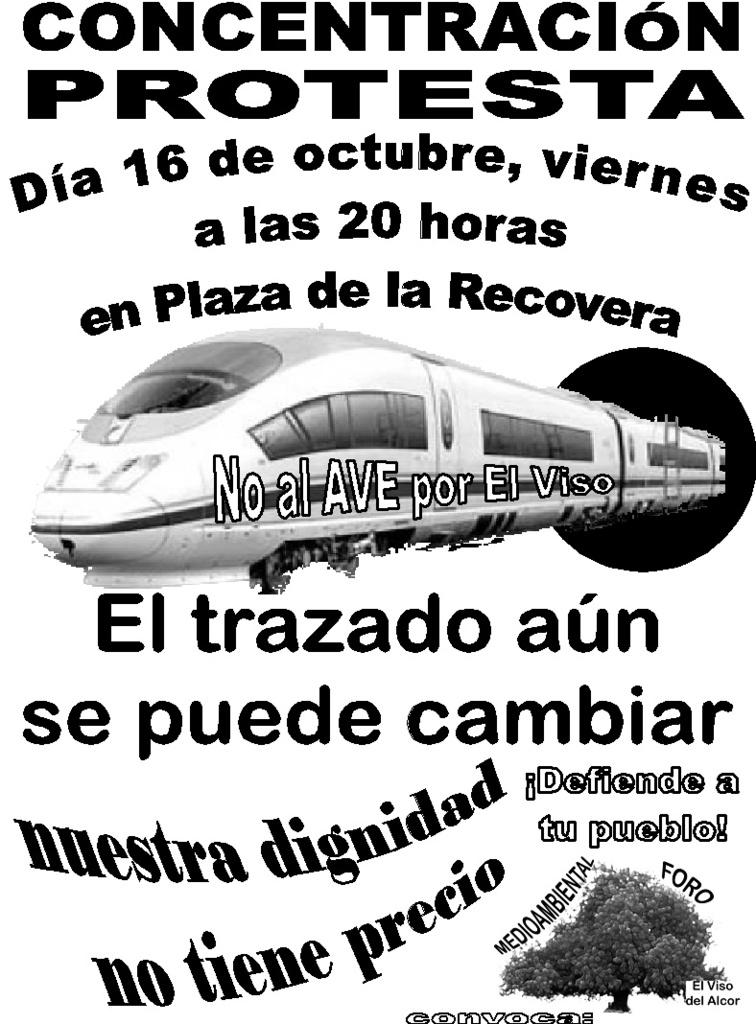What is the main subject of the image? There is a train in the center of the image. Can you describe anything else in the background of the image? Yes, there is text visible in the background of the image. What type of vegetation can be seen in the image? There is a tree in the bottom right corner of the image. What is the desire of the tree in the image? There is no indication of desire in the image, as trees do not have desires. 